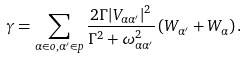Convert formula to latex. <formula><loc_0><loc_0><loc_500><loc_500>\gamma = \sum _ { \alpha \in o , \alpha ^ { \prime } \in p } \frac { 2 \Gamma | V _ { \alpha \alpha ^ { \prime } } | ^ { 2 } } { \Gamma ^ { 2 } + \omega _ { \alpha \alpha ^ { \prime } } ^ { 2 } } \left ( W _ { \alpha ^ { \prime } } + W _ { \alpha } \right ) .</formula> 